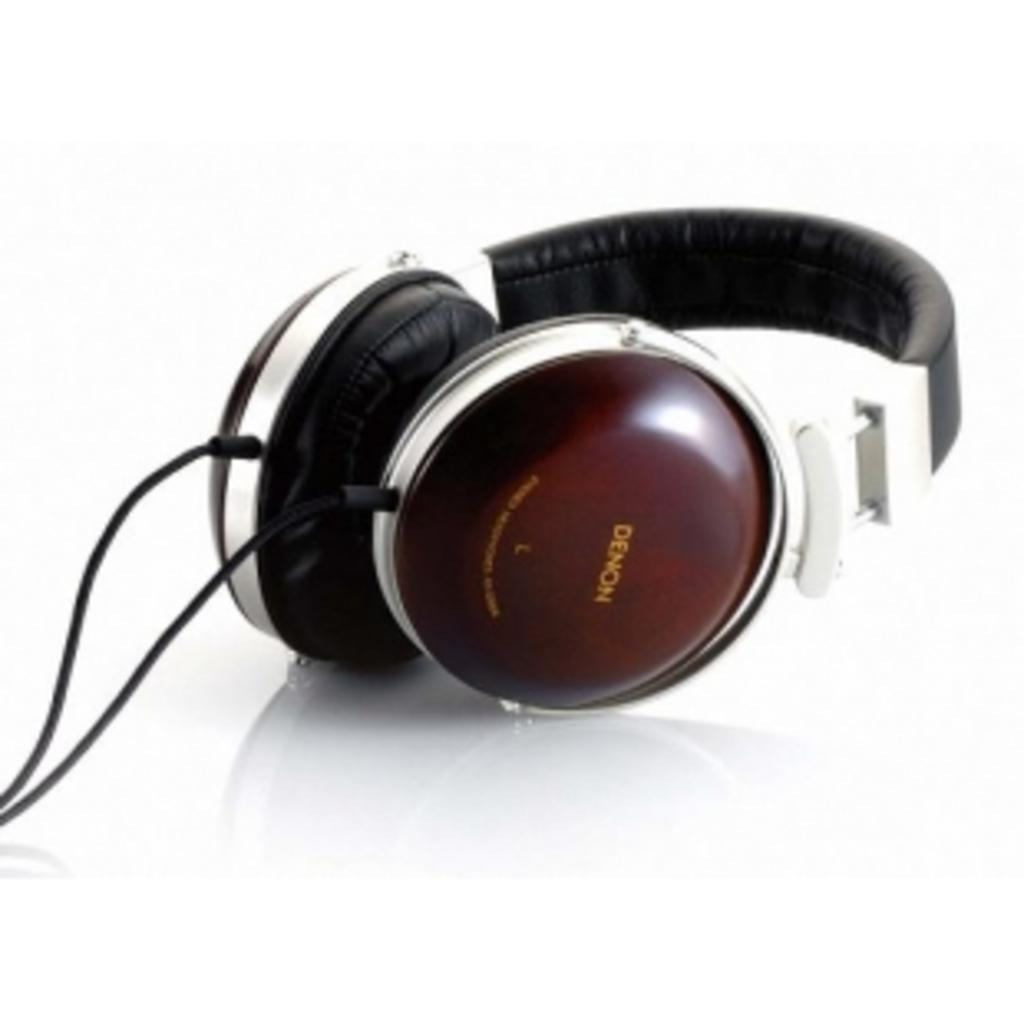What is the main object in the image? There is a headphone in the image. Can you describe the colors of the headphone? The headphone is brown, white, and black in color. What type of headphone is it based on its connectivity? The headphone is wired. How many oranges are being used as a cushion for the baby in the image? There is no baby or oranges present in the image; it only features a headphone. 